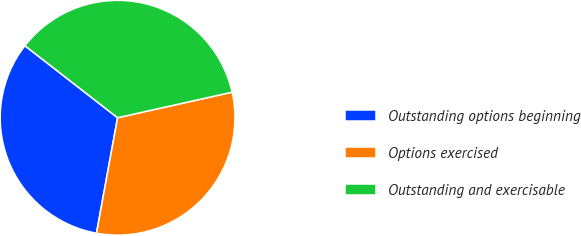Convert chart. <chart><loc_0><loc_0><loc_500><loc_500><pie_chart><fcel>Outstanding options beginning<fcel>Options exercised<fcel>Outstanding and exercisable<nl><fcel>32.64%<fcel>31.37%<fcel>35.99%<nl></chart> 